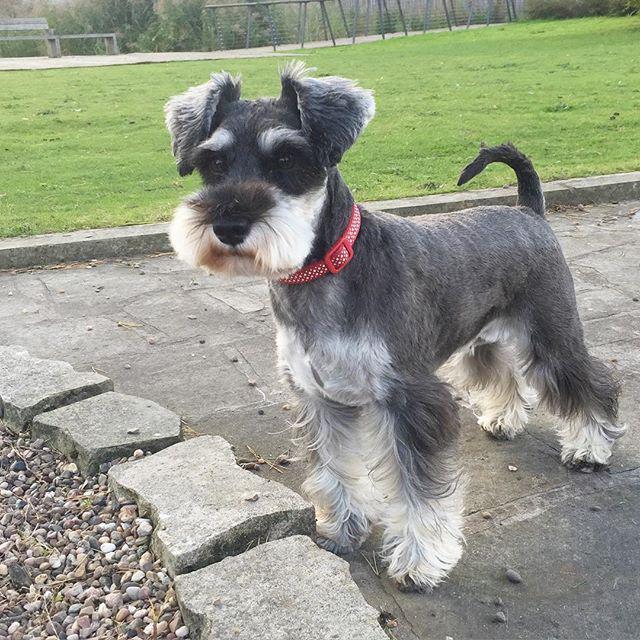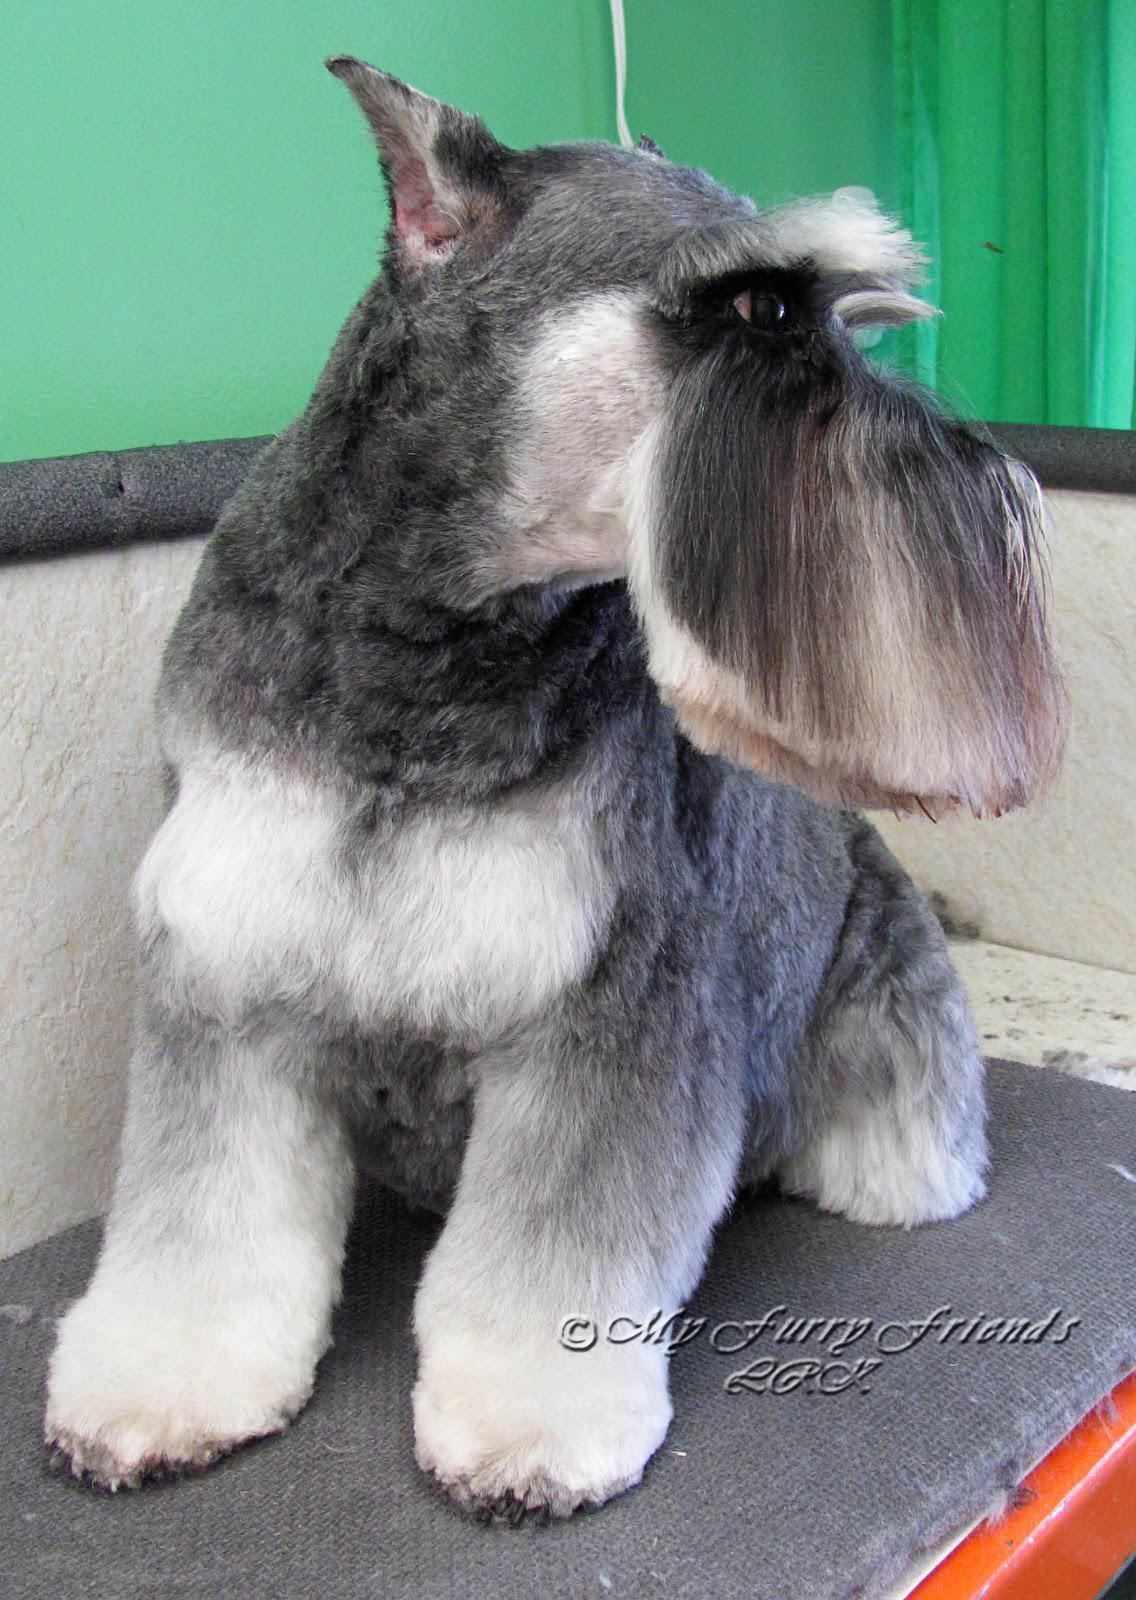The first image is the image on the left, the second image is the image on the right. Evaluate the accuracy of this statement regarding the images: "A dog is standing in front of a stone wall.". Is it true? Answer yes or no. No. The first image is the image on the left, the second image is the image on the right. Considering the images on both sides, is "Right image shows a dog standing outdoors in profile, with body turned leftward." valid? Answer yes or no. No. 